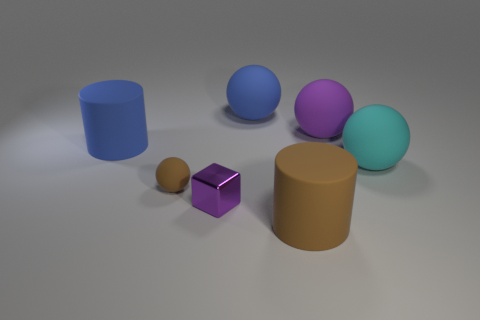Subtract 1 balls. How many balls are left? 3 Add 2 large red rubber spheres. How many objects exist? 9 Subtract all cylinders. How many objects are left? 5 Add 2 small things. How many small things are left? 4 Add 3 green cylinders. How many green cylinders exist? 3 Subtract 0 red blocks. How many objects are left? 7 Subtract all purple matte spheres. Subtract all small shiny things. How many objects are left? 5 